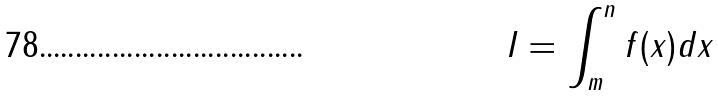<formula> <loc_0><loc_0><loc_500><loc_500>I = \int _ { m } ^ { n } f ( x ) d x</formula> 